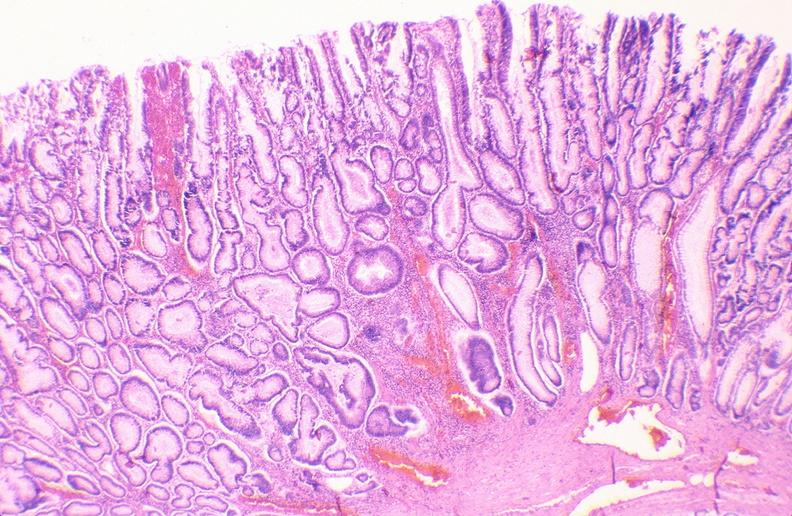where is this from?
Answer the question using a single word or phrase. Gastrointestinal system 